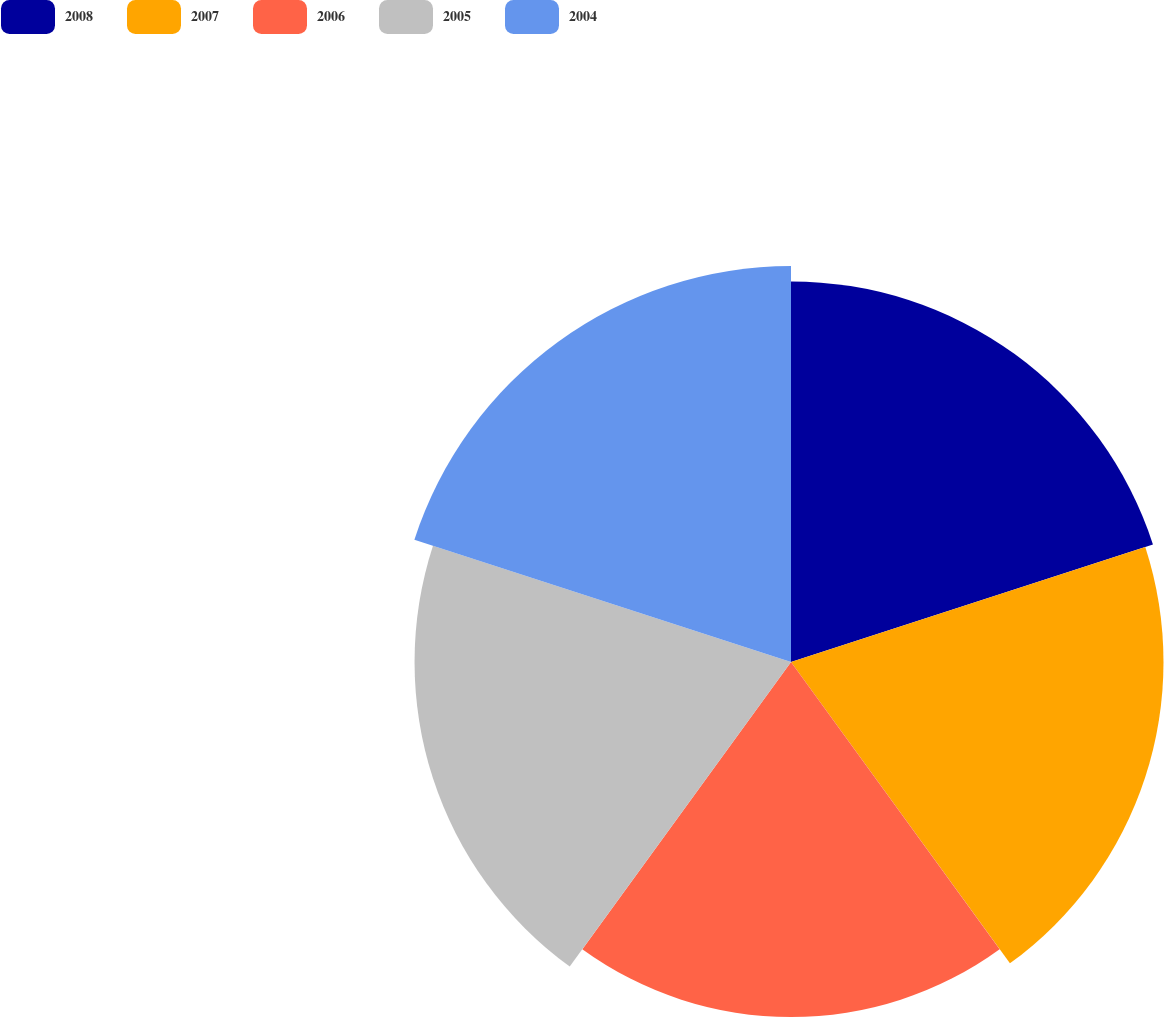Convert chart to OTSL. <chart><loc_0><loc_0><loc_500><loc_500><pie_chart><fcel>2008<fcel>2007<fcel>2006<fcel>2005<fcel>2004<nl><fcel>20.24%<fcel>19.81%<fcel>18.88%<fcel>20.02%<fcel>21.06%<nl></chart> 